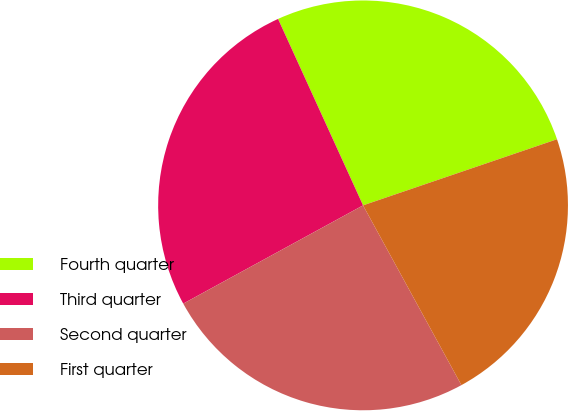<chart> <loc_0><loc_0><loc_500><loc_500><pie_chart><fcel>Fourth quarter<fcel>Third quarter<fcel>Second quarter<fcel>First quarter<nl><fcel>26.58%<fcel>26.15%<fcel>25.01%<fcel>22.26%<nl></chart> 